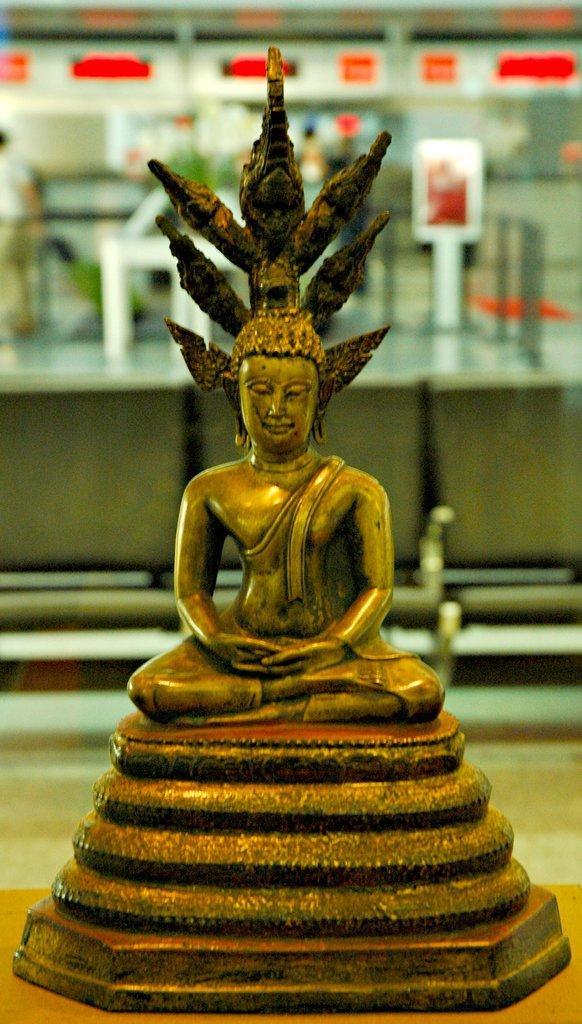How would you summarize this image in a sentence or two? In this image there is a small statue in the middle. 